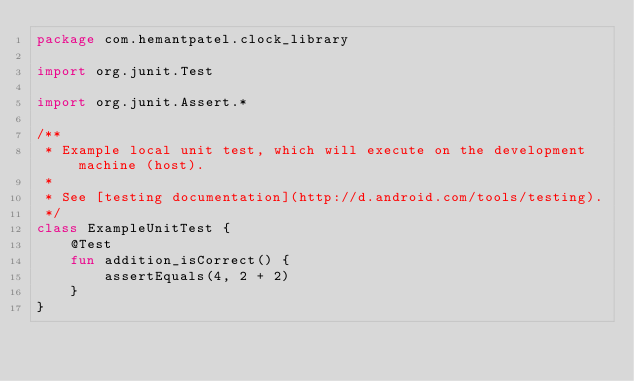Convert code to text. <code><loc_0><loc_0><loc_500><loc_500><_Kotlin_>package com.hemantpatel.clock_library

import org.junit.Test

import org.junit.Assert.*

/**
 * Example local unit test, which will execute on the development machine (host).
 *
 * See [testing documentation](http://d.android.com/tools/testing).
 */
class ExampleUnitTest {
    @Test
    fun addition_isCorrect() {
        assertEquals(4, 2 + 2)
    }
}</code> 